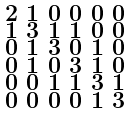<formula> <loc_0><loc_0><loc_500><loc_500>\begin{smallmatrix} 2 & 1 & 0 & 0 & 0 & 0 \\ 1 & 3 & 1 & 1 & 0 & 0 \\ 0 & 1 & 3 & 0 & 1 & 0 \\ 0 & 1 & 0 & 3 & 1 & 0 \\ 0 & 0 & 1 & 1 & 3 & 1 \\ 0 & 0 & 0 & 0 & 1 & 3 \end{smallmatrix}</formula> 